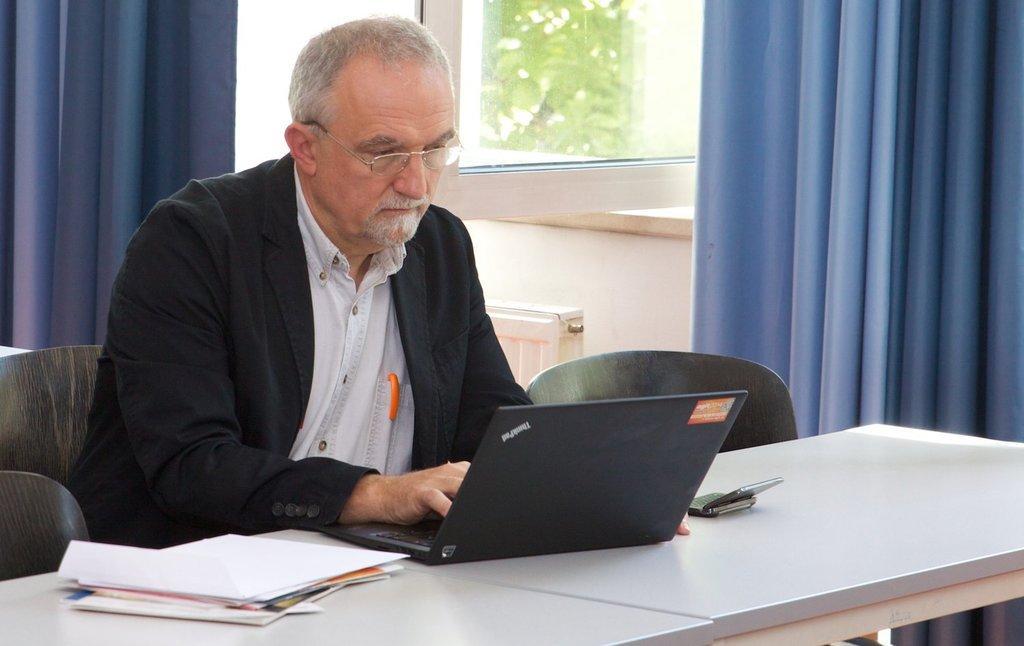Can you describe this image briefly? In this image I can see a man is sitting on a chair. On this table I can see a laptop and few more items. Here I can see curtains on window. 